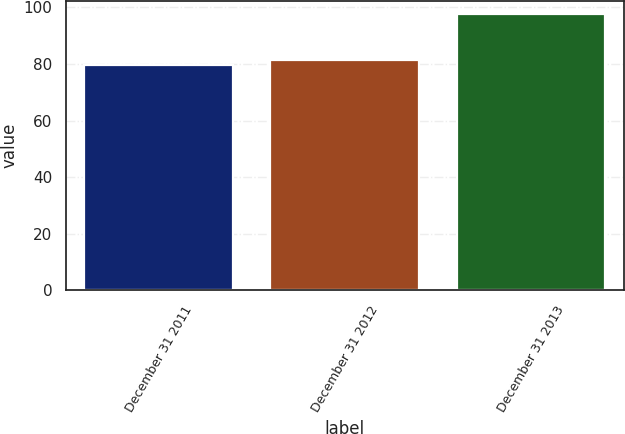Convert chart. <chart><loc_0><loc_0><loc_500><loc_500><bar_chart><fcel>December 31 2011<fcel>December 31 2012<fcel>December 31 2013<nl><fcel>79.66<fcel>81.44<fcel>97.46<nl></chart> 